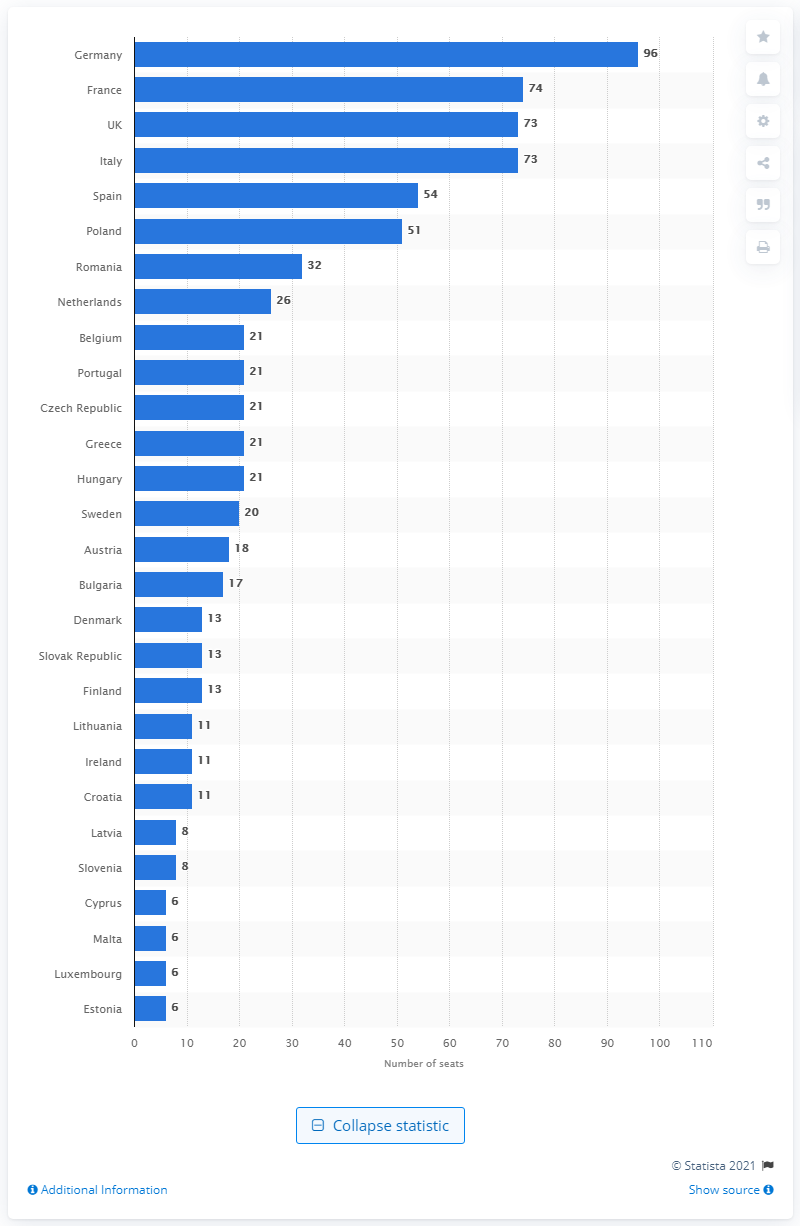Highlight a few significant elements in this photo. The United Kingdom currently holds 73 seats in the European Parliament. 